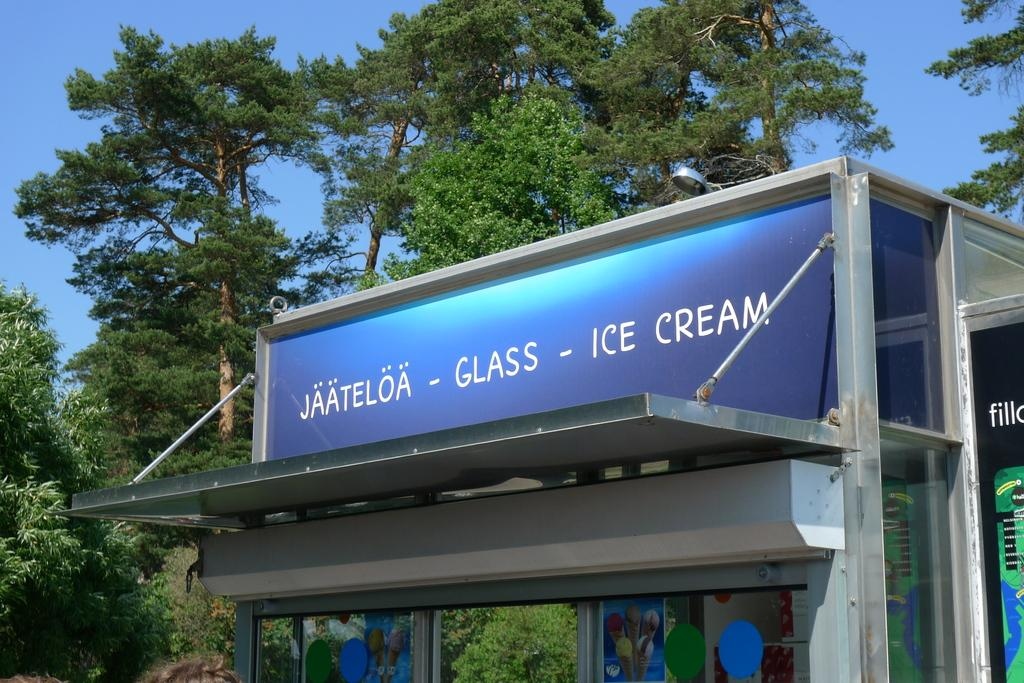What type of establishment is shown in the image? There is a store in the image. What can be seen in the background of the image? Trees are visible in the background of the image. What else is visible in the image besides the store and trees? The sky is visible in the image. What type of jam is being served for lunch in the image? There is no jam or lunch being served in the image; it features a store with trees and the sky visible in the background. 